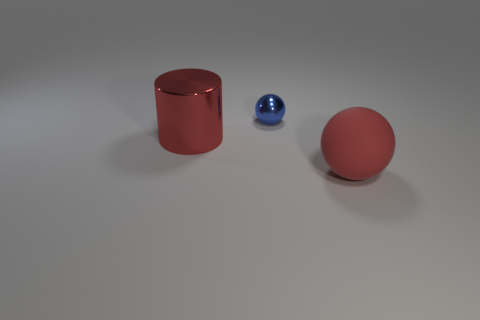Add 3 balls. How many objects exist? 6 Subtract all red matte things. Subtract all red cylinders. How many objects are left? 1 Add 3 metal balls. How many metal balls are left? 4 Add 2 cylinders. How many cylinders exist? 3 Subtract 1 blue spheres. How many objects are left? 2 Subtract all spheres. How many objects are left? 1 Subtract 1 balls. How many balls are left? 1 Subtract all gray cylinders. Subtract all red spheres. How many cylinders are left? 1 Subtract all green blocks. How many green spheres are left? 0 